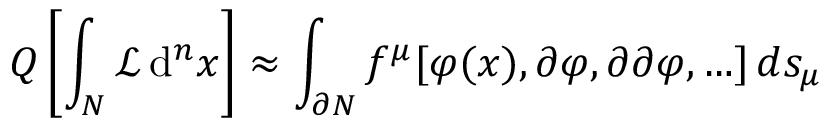Convert formula to latex. <formula><loc_0><loc_0><loc_500><loc_500>Q \left [ \int _ { N } { \mathcal { L } } \, d ^ { n } x \right ] \approx \int _ { \partial N } f ^ { \mu } [ \varphi ( x ) , \partial \varphi , \partial \partial \varphi , \dots ] \, d s _ { \mu }</formula> 